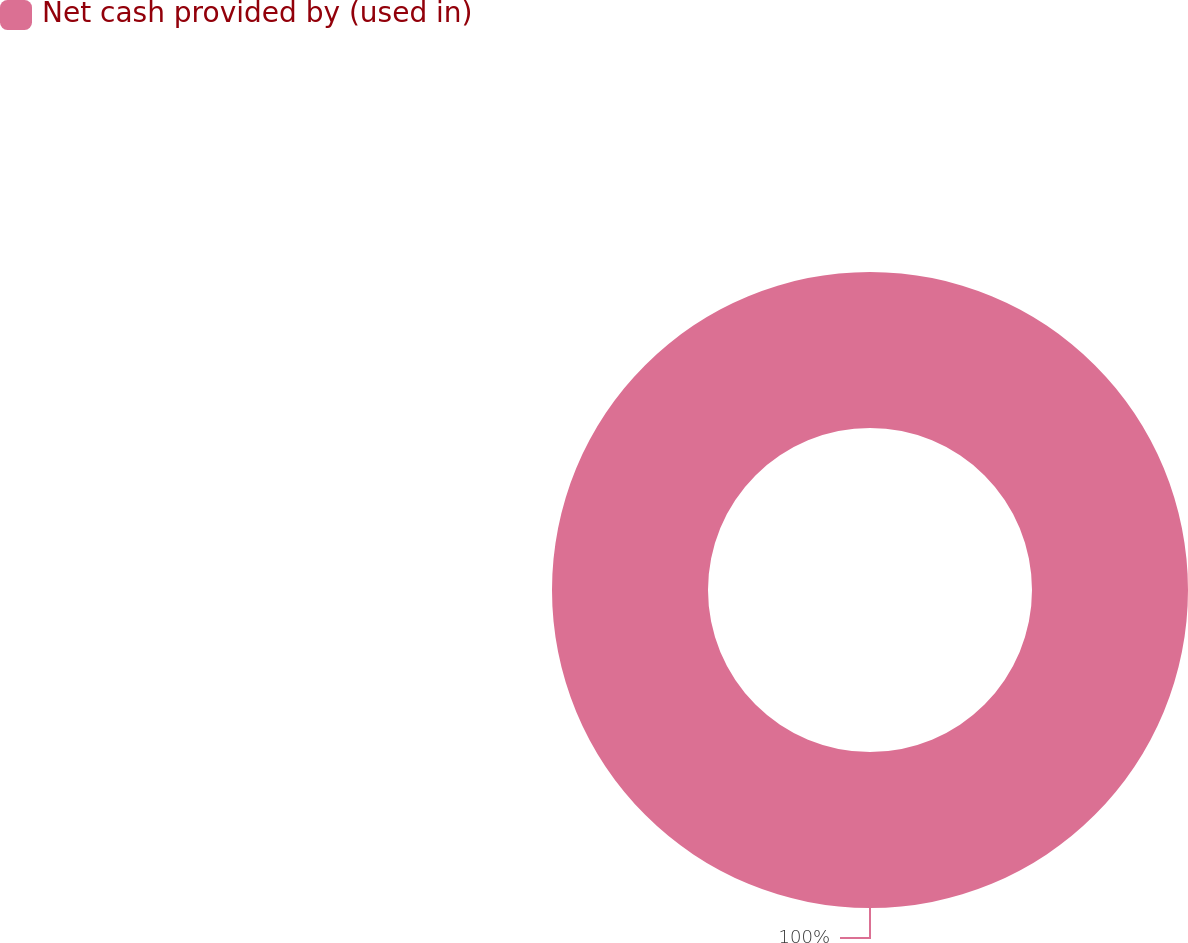Convert chart. <chart><loc_0><loc_0><loc_500><loc_500><pie_chart><fcel>Net cash provided by (used in)<nl><fcel>100.0%<nl></chart> 